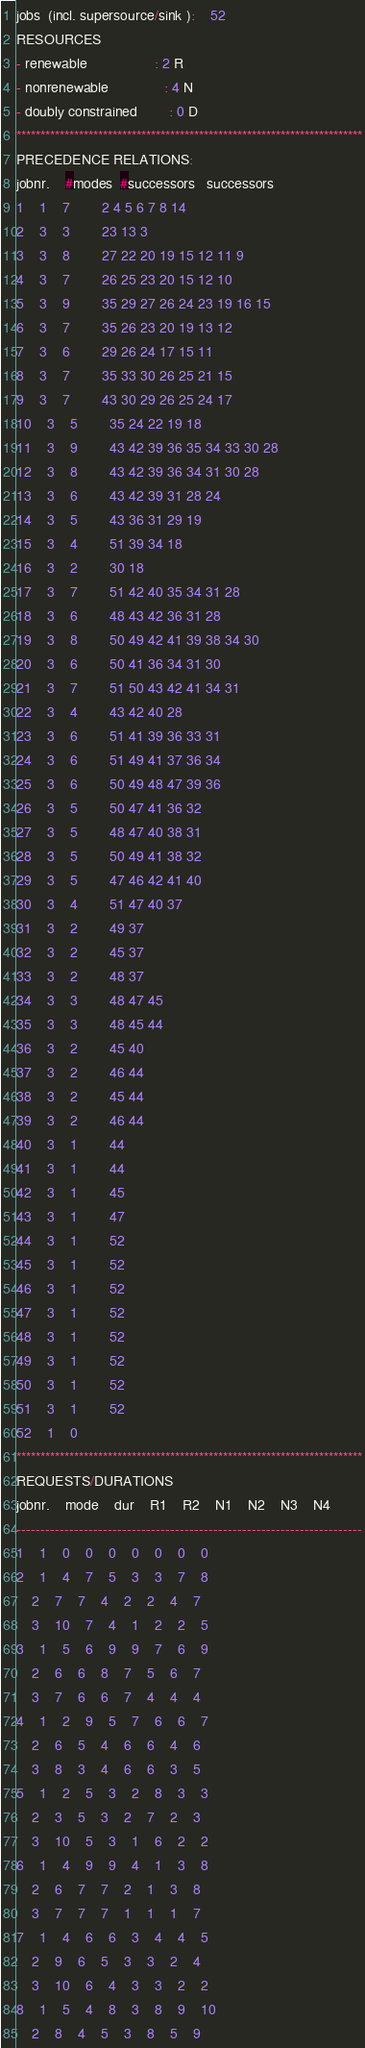Convert code to text. <code><loc_0><loc_0><loc_500><loc_500><_ObjectiveC_>jobs  (incl. supersource/sink ):	52
RESOURCES
- renewable                 : 2 R
- nonrenewable              : 4 N
- doubly constrained        : 0 D
************************************************************************
PRECEDENCE RELATIONS:
jobnr.    #modes  #successors   successors
1	1	7		2 4 5 6 7 8 14 
2	3	3		23 13 3 
3	3	8		27 22 20 19 15 12 11 9 
4	3	7		26 25 23 20 15 12 10 
5	3	9		35 29 27 26 24 23 19 16 15 
6	3	7		35 26 23 20 19 13 12 
7	3	6		29 26 24 17 15 11 
8	3	7		35 33 30 26 25 21 15 
9	3	7		43 30 29 26 25 24 17 
10	3	5		35 24 22 19 18 
11	3	9		43 42 39 36 35 34 33 30 28 
12	3	8		43 42 39 36 34 31 30 28 
13	3	6		43 42 39 31 28 24 
14	3	5		43 36 31 29 19 
15	3	4		51 39 34 18 
16	3	2		30 18 
17	3	7		51 42 40 35 34 31 28 
18	3	6		48 43 42 36 31 28 
19	3	8		50 49 42 41 39 38 34 30 
20	3	6		50 41 36 34 31 30 
21	3	7		51 50 43 42 41 34 31 
22	3	4		43 42 40 28 
23	3	6		51 41 39 36 33 31 
24	3	6		51 49 41 37 36 34 
25	3	6		50 49 48 47 39 36 
26	3	5		50 47 41 36 32 
27	3	5		48 47 40 38 31 
28	3	5		50 49 41 38 32 
29	3	5		47 46 42 41 40 
30	3	4		51 47 40 37 
31	3	2		49 37 
32	3	2		45 37 
33	3	2		48 37 
34	3	3		48 47 45 
35	3	3		48 45 44 
36	3	2		45 40 
37	3	2		46 44 
38	3	2		45 44 
39	3	2		46 44 
40	3	1		44 
41	3	1		44 
42	3	1		45 
43	3	1		47 
44	3	1		52 
45	3	1		52 
46	3	1		52 
47	3	1		52 
48	3	1		52 
49	3	1		52 
50	3	1		52 
51	3	1		52 
52	1	0		
************************************************************************
REQUESTS/DURATIONS
jobnr.	mode	dur	R1	R2	N1	N2	N3	N4	
------------------------------------------------------------------------
1	1	0	0	0	0	0	0	0	
2	1	4	7	5	3	3	7	8	
	2	7	7	4	2	2	4	7	
	3	10	7	4	1	2	2	5	
3	1	5	6	9	9	7	6	9	
	2	6	6	8	7	5	6	7	
	3	7	6	6	7	4	4	4	
4	1	2	9	5	7	6	6	7	
	2	6	5	4	6	6	4	6	
	3	8	3	4	6	6	3	5	
5	1	2	5	3	2	8	3	3	
	2	3	5	3	2	7	2	3	
	3	10	5	3	1	6	2	2	
6	1	4	9	9	4	1	3	8	
	2	6	7	7	2	1	3	8	
	3	7	7	7	1	1	1	7	
7	1	4	6	6	3	4	4	5	
	2	9	6	5	3	3	2	4	
	3	10	6	4	3	3	2	2	
8	1	5	4	8	3	8	9	10	
	2	8	4	5	3	8	5	9	</code> 